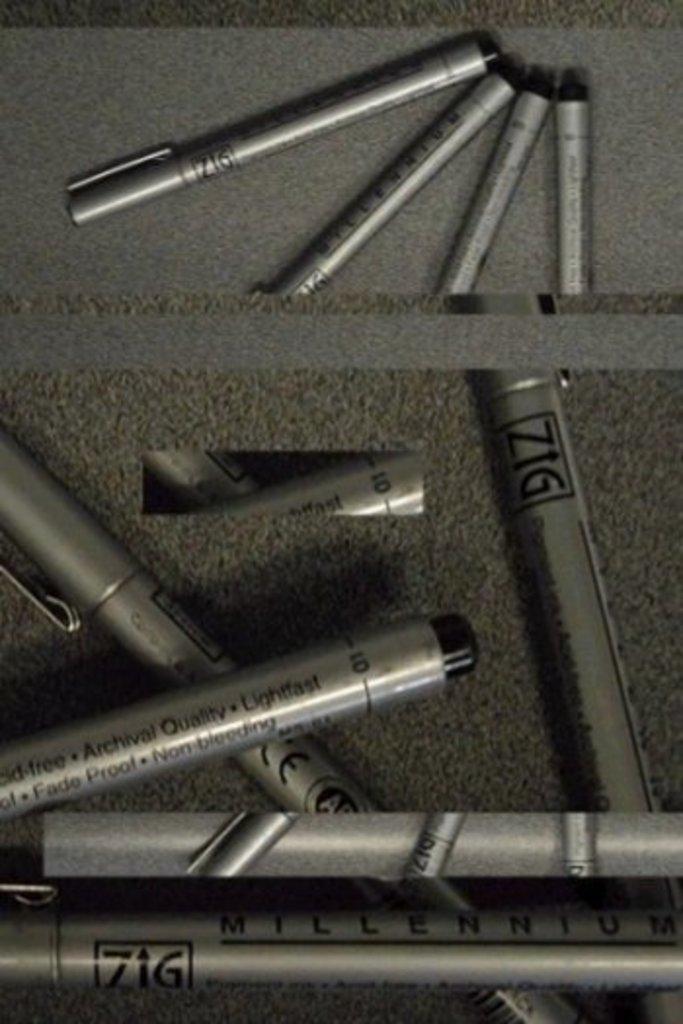Describe this image in one or two sentences. In this image I can see the black and ash color pens. These are on the ash color surface. 